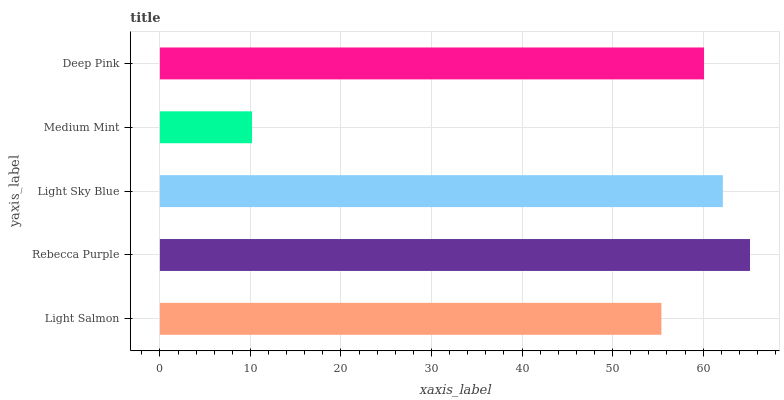Is Medium Mint the minimum?
Answer yes or no. Yes. Is Rebecca Purple the maximum?
Answer yes or no. Yes. Is Light Sky Blue the minimum?
Answer yes or no. No. Is Light Sky Blue the maximum?
Answer yes or no. No. Is Rebecca Purple greater than Light Sky Blue?
Answer yes or no. Yes. Is Light Sky Blue less than Rebecca Purple?
Answer yes or no. Yes. Is Light Sky Blue greater than Rebecca Purple?
Answer yes or no. No. Is Rebecca Purple less than Light Sky Blue?
Answer yes or no. No. Is Deep Pink the high median?
Answer yes or no. Yes. Is Deep Pink the low median?
Answer yes or no. Yes. Is Light Salmon the high median?
Answer yes or no. No. Is Rebecca Purple the low median?
Answer yes or no. No. 